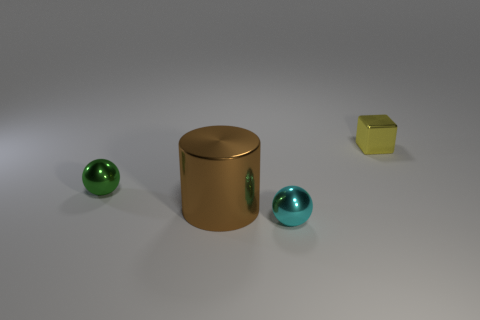Are there any other things that are the same size as the brown object?
Provide a succinct answer. No. How many brown things have the same material as the green thing?
Your response must be concise. 1. Do the cyan object and the brown metal object have the same shape?
Ensure brevity in your answer.  No. There is a ball behind the metallic sphere that is in front of the small metal sphere behind the big metal cylinder; what size is it?
Keep it short and to the point. Small. There is a small thing to the left of the cyan object; are there any small cyan shiny things left of it?
Give a very brief answer. No. How many things are to the left of the small metallic thing right of the tiny object that is in front of the green object?
Your response must be concise. 3. The thing that is both to the right of the big brown shiny object and in front of the tiny green sphere is what color?
Your answer should be very brief. Cyan. How many large shiny things are the same color as the cylinder?
Ensure brevity in your answer.  0. What number of spheres are either brown objects or yellow metallic objects?
Keep it short and to the point. 0. The metal sphere that is the same size as the cyan shiny object is what color?
Offer a terse response. Green. 